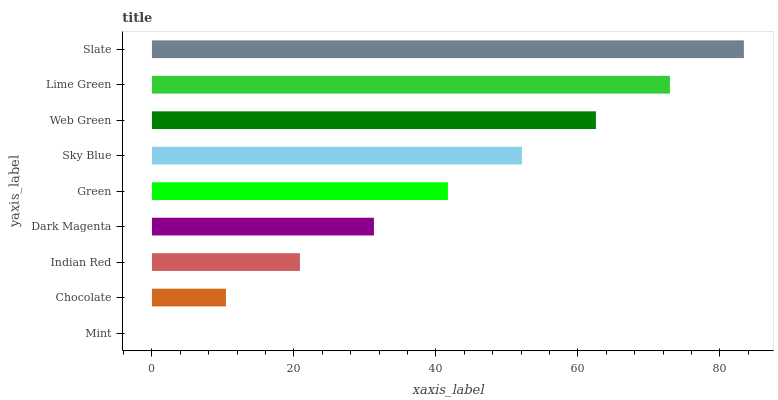Is Mint the minimum?
Answer yes or no. Yes. Is Slate the maximum?
Answer yes or no. Yes. Is Chocolate the minimum?
Answer yes or no. No. Is Chocolate the maximum?
Answer yes or no. No. Is Chocolate greater than Mint?
Answer yes or no. Yes. Is Mint less than Chocolate?
Answer yes or no. Yes. Is Mint greater than Chocolate?
Answer yes or no. No. Is Chocolate less than Mint?
Answer yes or no. No. Is Green the high median?
Answer yes or no. Yes. Is Green the low median?
Answer yes or no. Yes. Is Indian Red the high median?
Answer yes or no. No. Is Web Green the low median?
Answer yes or no. No. 